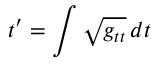<formula> <loc_0><loc_0><loc_500><loc_500>t ^ { \prime } = \int \sqrt { g _ { t t } } \, d t</formula> 